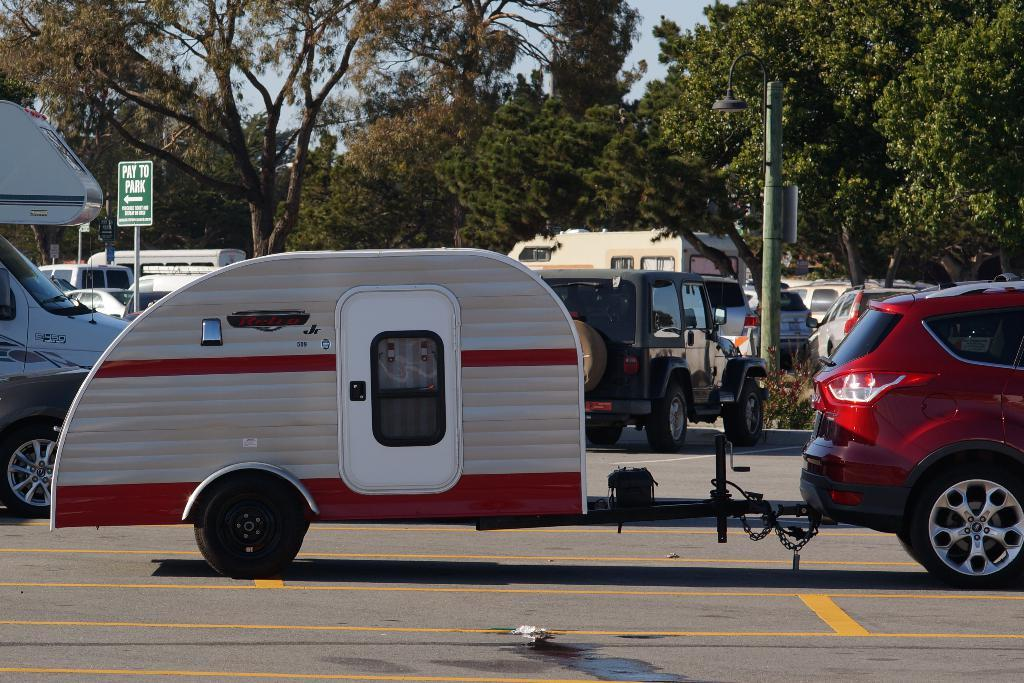<image>
Present a compact description of the photo's key features. a green sign behind the teardrop camper says pay to park 